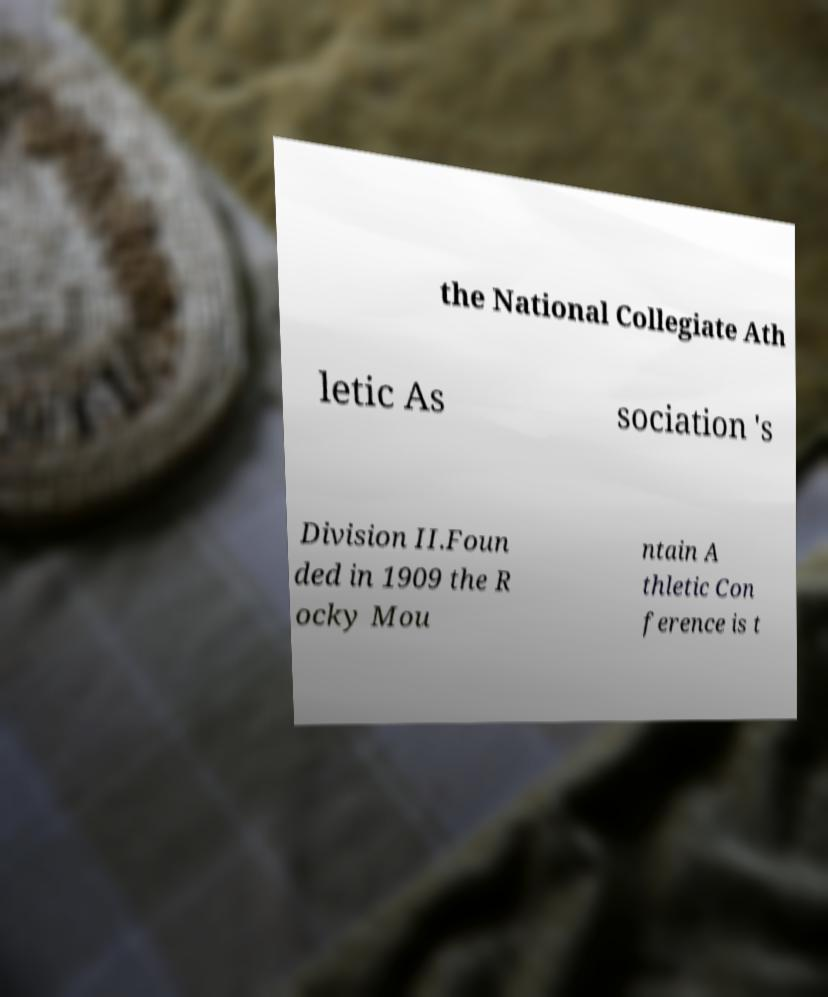Could you assist in decoding the text presented in this image and type it out clearly? the National Collegiate Ath letic As sociation 's Division II.Foun ded in 1909 the R ocky Mou ntain A thletic Con ference is t 